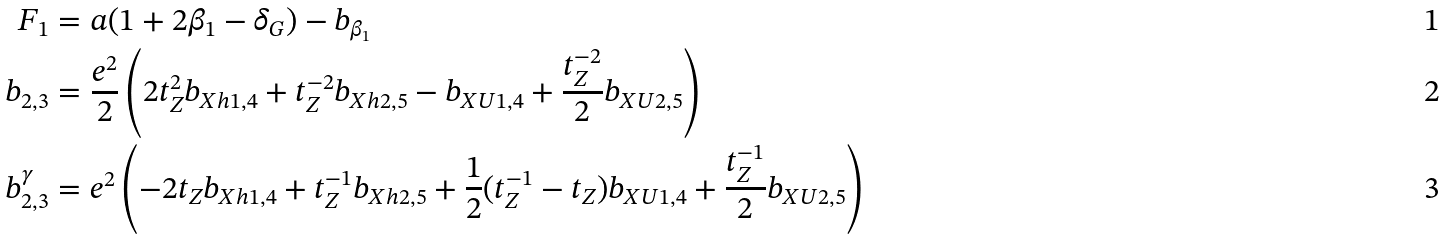Convert formula to latex. <formula><loc_0><loc_0><loc_500><loc_500>F _ { 1 } & = a ( 1 + 2 \beta _ { 1 } - \delta _ { G } ) - b _ { \beta _ { 1 } } \\ b _ { 2 , 3 } & = \frac { e ^ { 2 } } { 2 } \left ( 2 t _ { Z } ^ { 2 } b _ { X h 1 , 4 } + t _ { Z } ^ { - 2 } b _ { X h 2 , 5 } - b _ { X U 1 , 4 } + \frac { t _ { Z } ^ { - 2 } } { 2 } b _ { X U 2 , 5 } \right ) \\ b _ { 2 , 3 } ^ { \gamma } & = e ^ { 2 } \left ( - 2 t _ { Z } b _ { X h 1 , 4 } + t _ { Z } ^ { - 1 } b _ { X h 2 , 5 } + \frac { 1 } { 2 } ( t _ { Z } ^ { - 1 } - t _ { Z } ) b _ { X U 1 , 4 } + \frac { t _ { Z } ^ { - 1 } } { 2 } b _ { X U 2 , 5 } \right )</formula> 